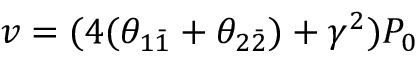<formula> <loc_0><loc_0><loc_500><loc_500>v = ( 4 ( \theta _ { 1 \bar { 1 } } + \theta _ { 2 \bar { 2 } } ) + \gamma ^ { 2 } ) P _ { 0 }</formula> 